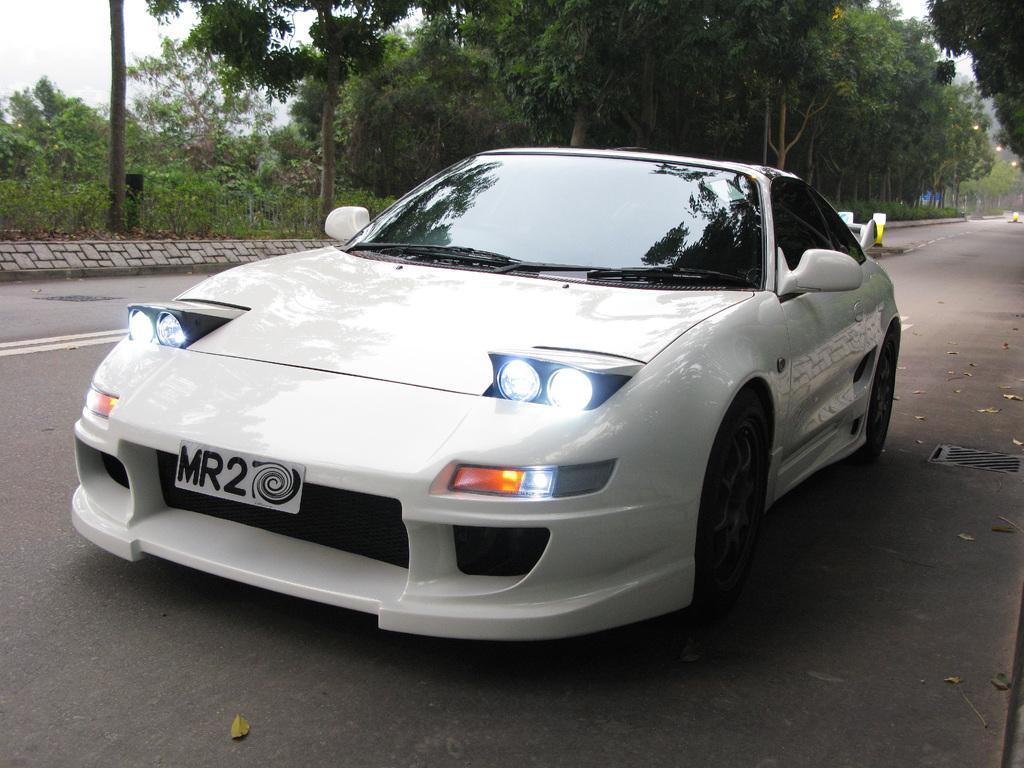How would you summarize this image in a sentence or two? In this image I can see in the middle it is a car in white color. At the back side there are trees, on the right side there are lights. 